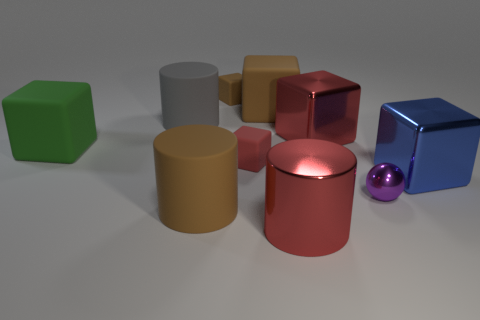The rubber object that is the same color as the metal cylinder is what size?
Ensure brevity in your answer.  Small. Are there any purple cylinders made of the same material as the big blue block?
Offer a very short reply. No. Is the number of large metal cubes to the right of the purple metal ball the same as the number of red shiny cylinders in front of the blue thing?
Keep it short and to the point. Yes. There is a red object that is in front of the tiny purple object; what is its size?
Make the answer very short. Large. What is the big cylinder that is behind the big red object that is behind the large red metal cylinder made of?
Your response must be concise. Rubber. There is a matte cylinder that is in front of the large rubber cylinder behind the blue shiny block; how many large matte cylinders are left of it?
Offer a terse response. 1. Does the brown object that is in front of the gray rubber object have the same material as the red block that is behind the large green rubber cube?
Provide a succinct answer. No. There is a big thing that is the same color as the metallic cylinder; what is its material?
Your answer should be compact. Metal. How many metallic things have the same shape as the small brown rubber object?
Ensure brevity in your answer.  2. Is the number of blue shiny things that are left of the small brown cube greater than the number of tiny rubber cylinders?
Your answer should be very brief. No. 